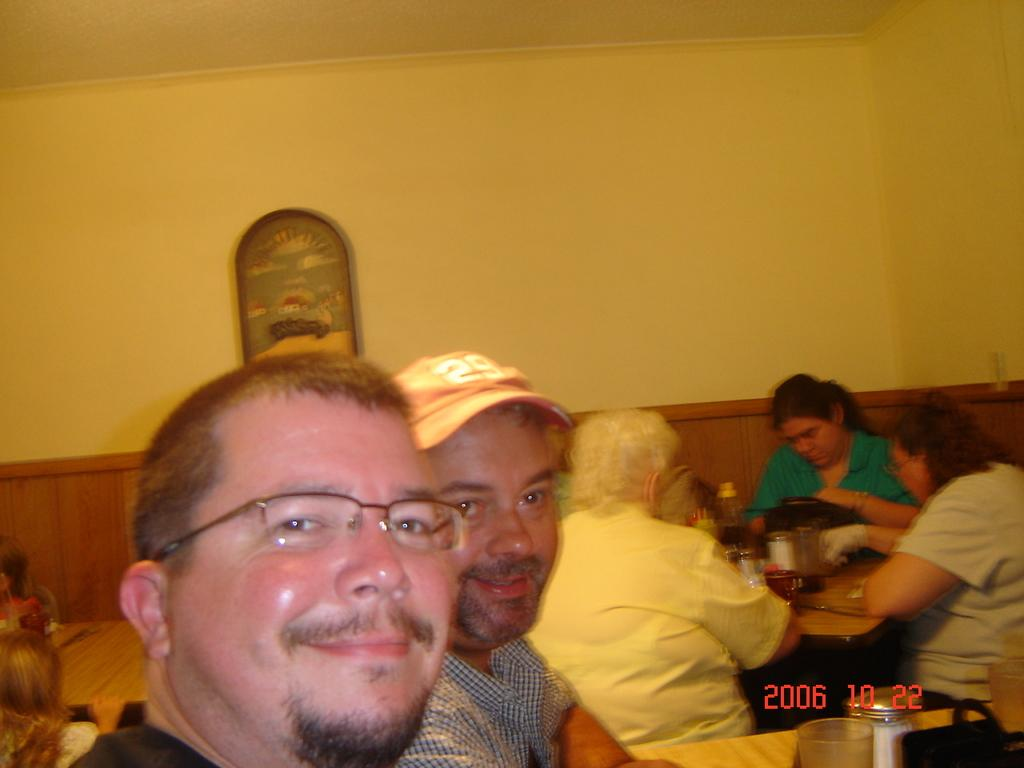How many people are in the image? There are two men in the image. What is the facial expression of the men in the image? The men are smiling. Can you describe the setting where the men are located? There are people sitting around a dining table. What type of eggnog is being served at the harbor in the image? There is no harbor or eggnog present in the image; it features two men smiling and people sitting around a dining table. 